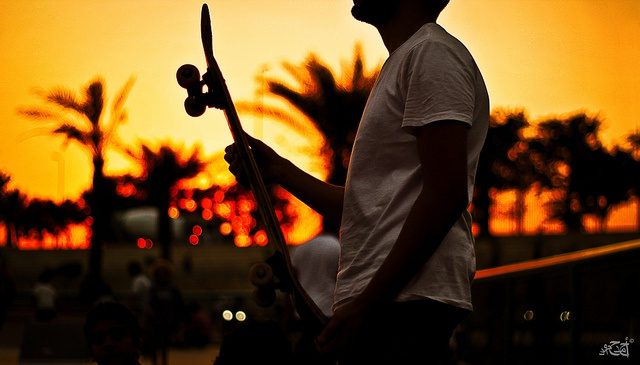Describe the objects in this image and their specific colors. I can see people in orange, black, maroon, and gray tones and skateboard in orange, black, maroon, and lightyellow tones in this image. 